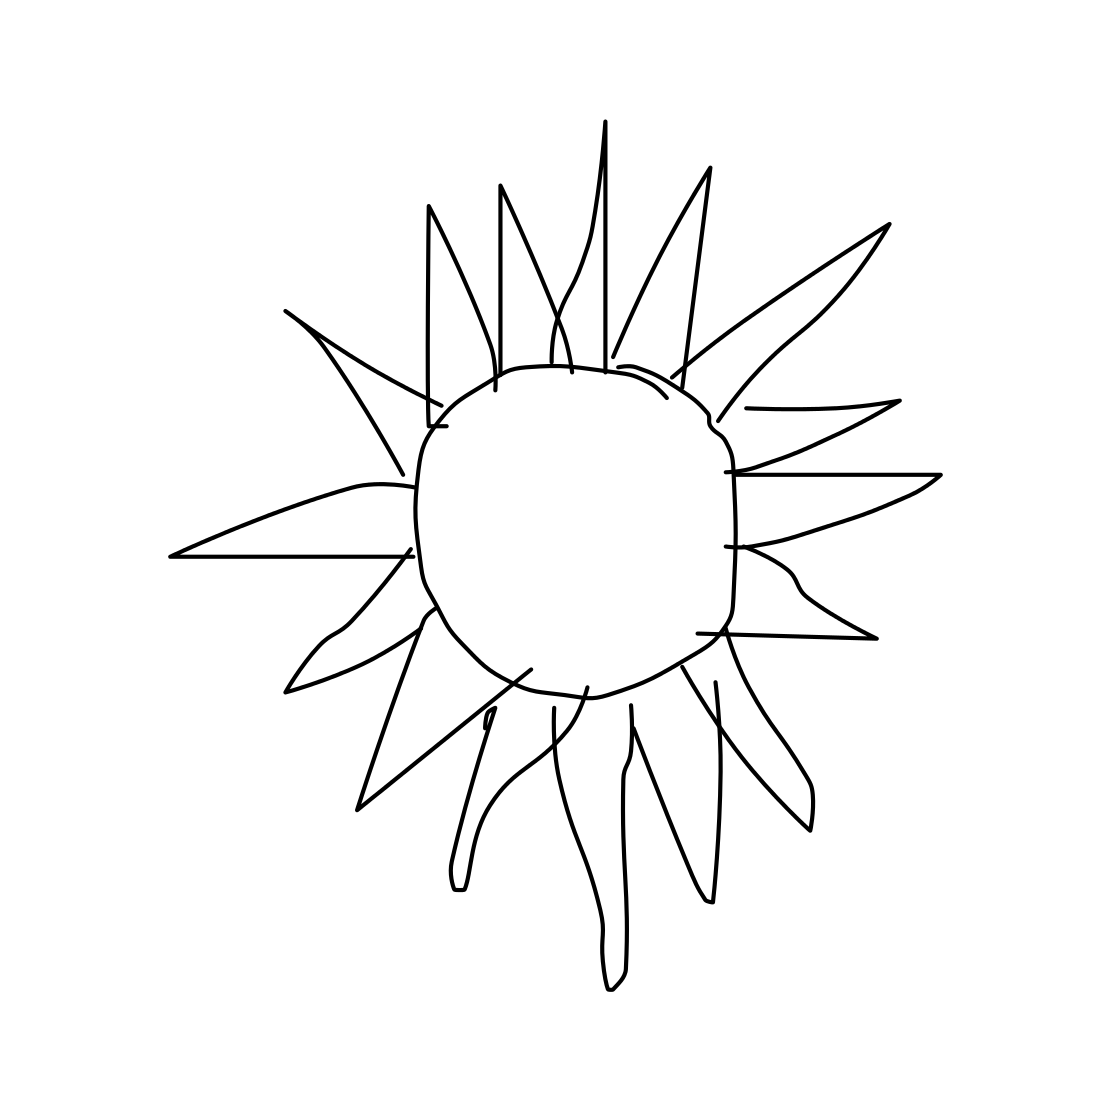Could this image be symbolic of something? Certainly! The sun often symbolizes vitality, life, and energy. Its depiction here, although simplistic, might be an artist's expression of optimism or the natural world's constancy. Would this image suit educational material for children? Yes, its simple and clear design is ideal for educational contexts, especially for young children, as it is easily recognizable and can be visually engaging without overwhelming detail. 